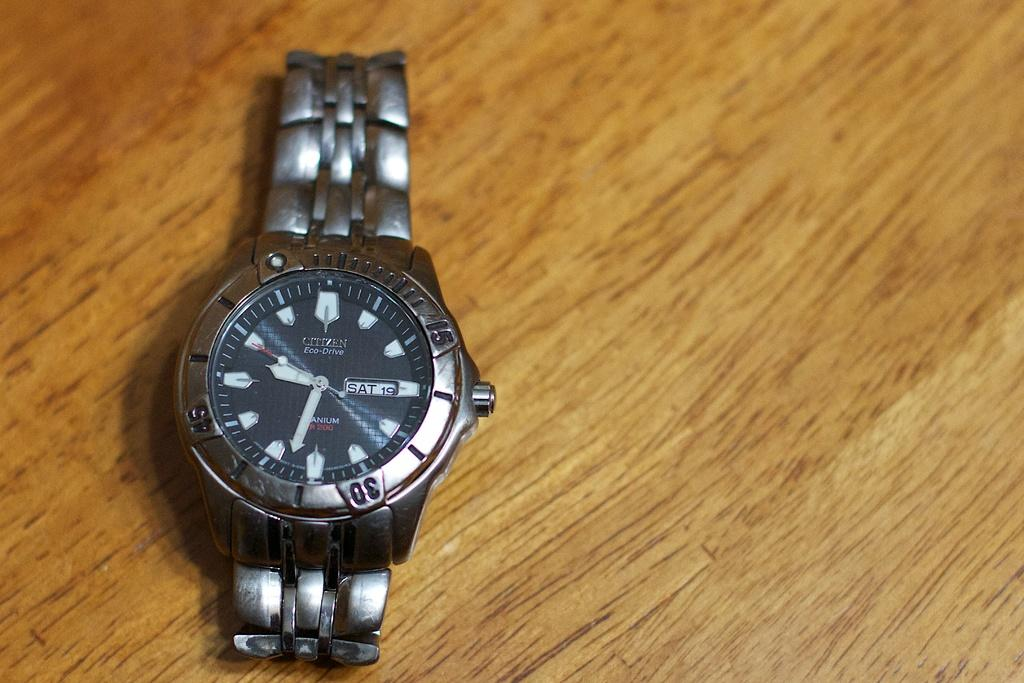<image>
Present a compact description of the photo's key features. The brand of watch on the table is a Citizen 